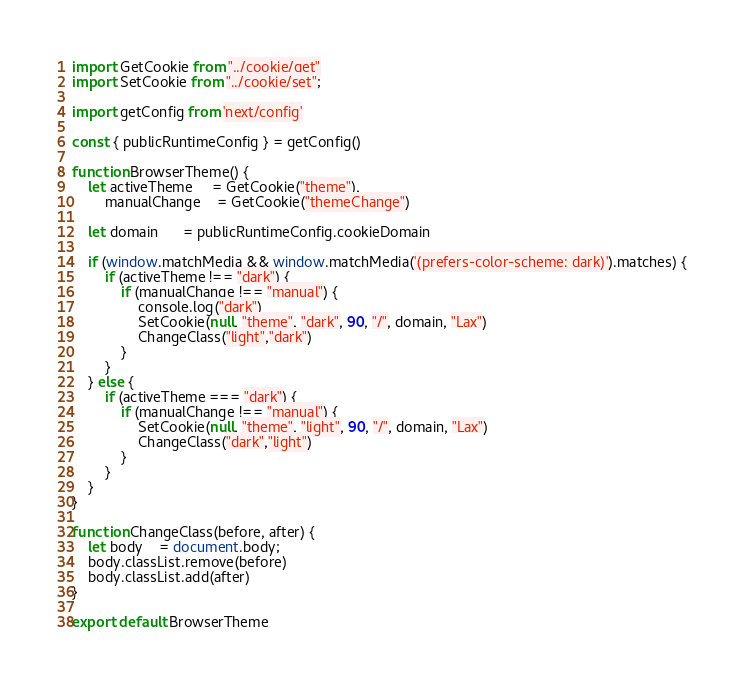<code> <loc_0><loc_0><loc_500><loc_500><_JavaScript_>import GetCookie from "../cookie/get"
import SetCookie from "../cookie/set";

import getConfig from 'next/config'

const { publicRuntimeConfig } = getConfig()

function BrowserTheme() {
    let activeTheme     = GetCookie("theme"),
        manualChange    = GetCookie("themeChange")

    let domain      = publicRuntimeConfig.cookieDomain

    if (window.matchMedia && window.matchMedia('(prefers-color-scheme: dark)').matches) {
        if (activeTheme !== "dark") {
            if (manualChange !== "manual") {
                console.log("dark")
                SetCookie(null, "theme", "dark", 90, "/", domain, "Lax")
                ChangeClass("light","dark")
            }
        }
    } else {
        if (activeTheme === "dark") {
            if (manualChange !== "manual") {
                SetCookie(null, "theme", "light", 90, "/", domain, "Lax")
                ChangeClass("dark","light")
            }
        }
    }
}

function ChangeClass(before, after) {
    let body    = document.body;
    body.classList.remove(before)
    body.classList.add(after)
}

export default BrowserTheme</code> 